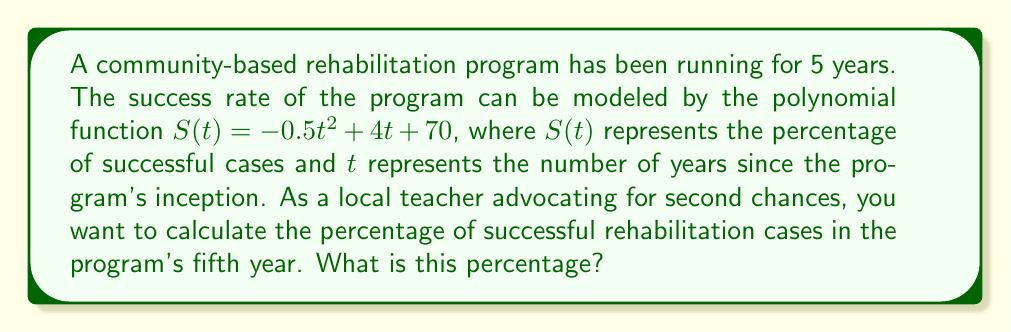Show me your answer to this math problem. To solve this problem, we need to follow these steps:

1) We are given the polynomial function: $S(t) = -0.5t^2 + 4t + 70$

2) We need to find $S(5)$, as we want to know the percentage of successful cases in the fifth year.

3) Let's substitute $t = 5$ into the function:

   $S(5) = -0.5(5)^2 + 4(5) + 70$

4) Now, let's calculate step by step:
   
   $S(5) = -0.5(25) + 20 + 70$
   
   $S(5) = -12.5 + 20 + 70$
   
   $S(5) = 77.5$

5) Therefore, in the fifth year, the percentage of successful rehabilitation cases is 77.5%.

This result shows that despite an initial increase, the success rate starts to decline after a certain point, which is valuable information for program evaluation and improvement.
Answer: 77.5% 